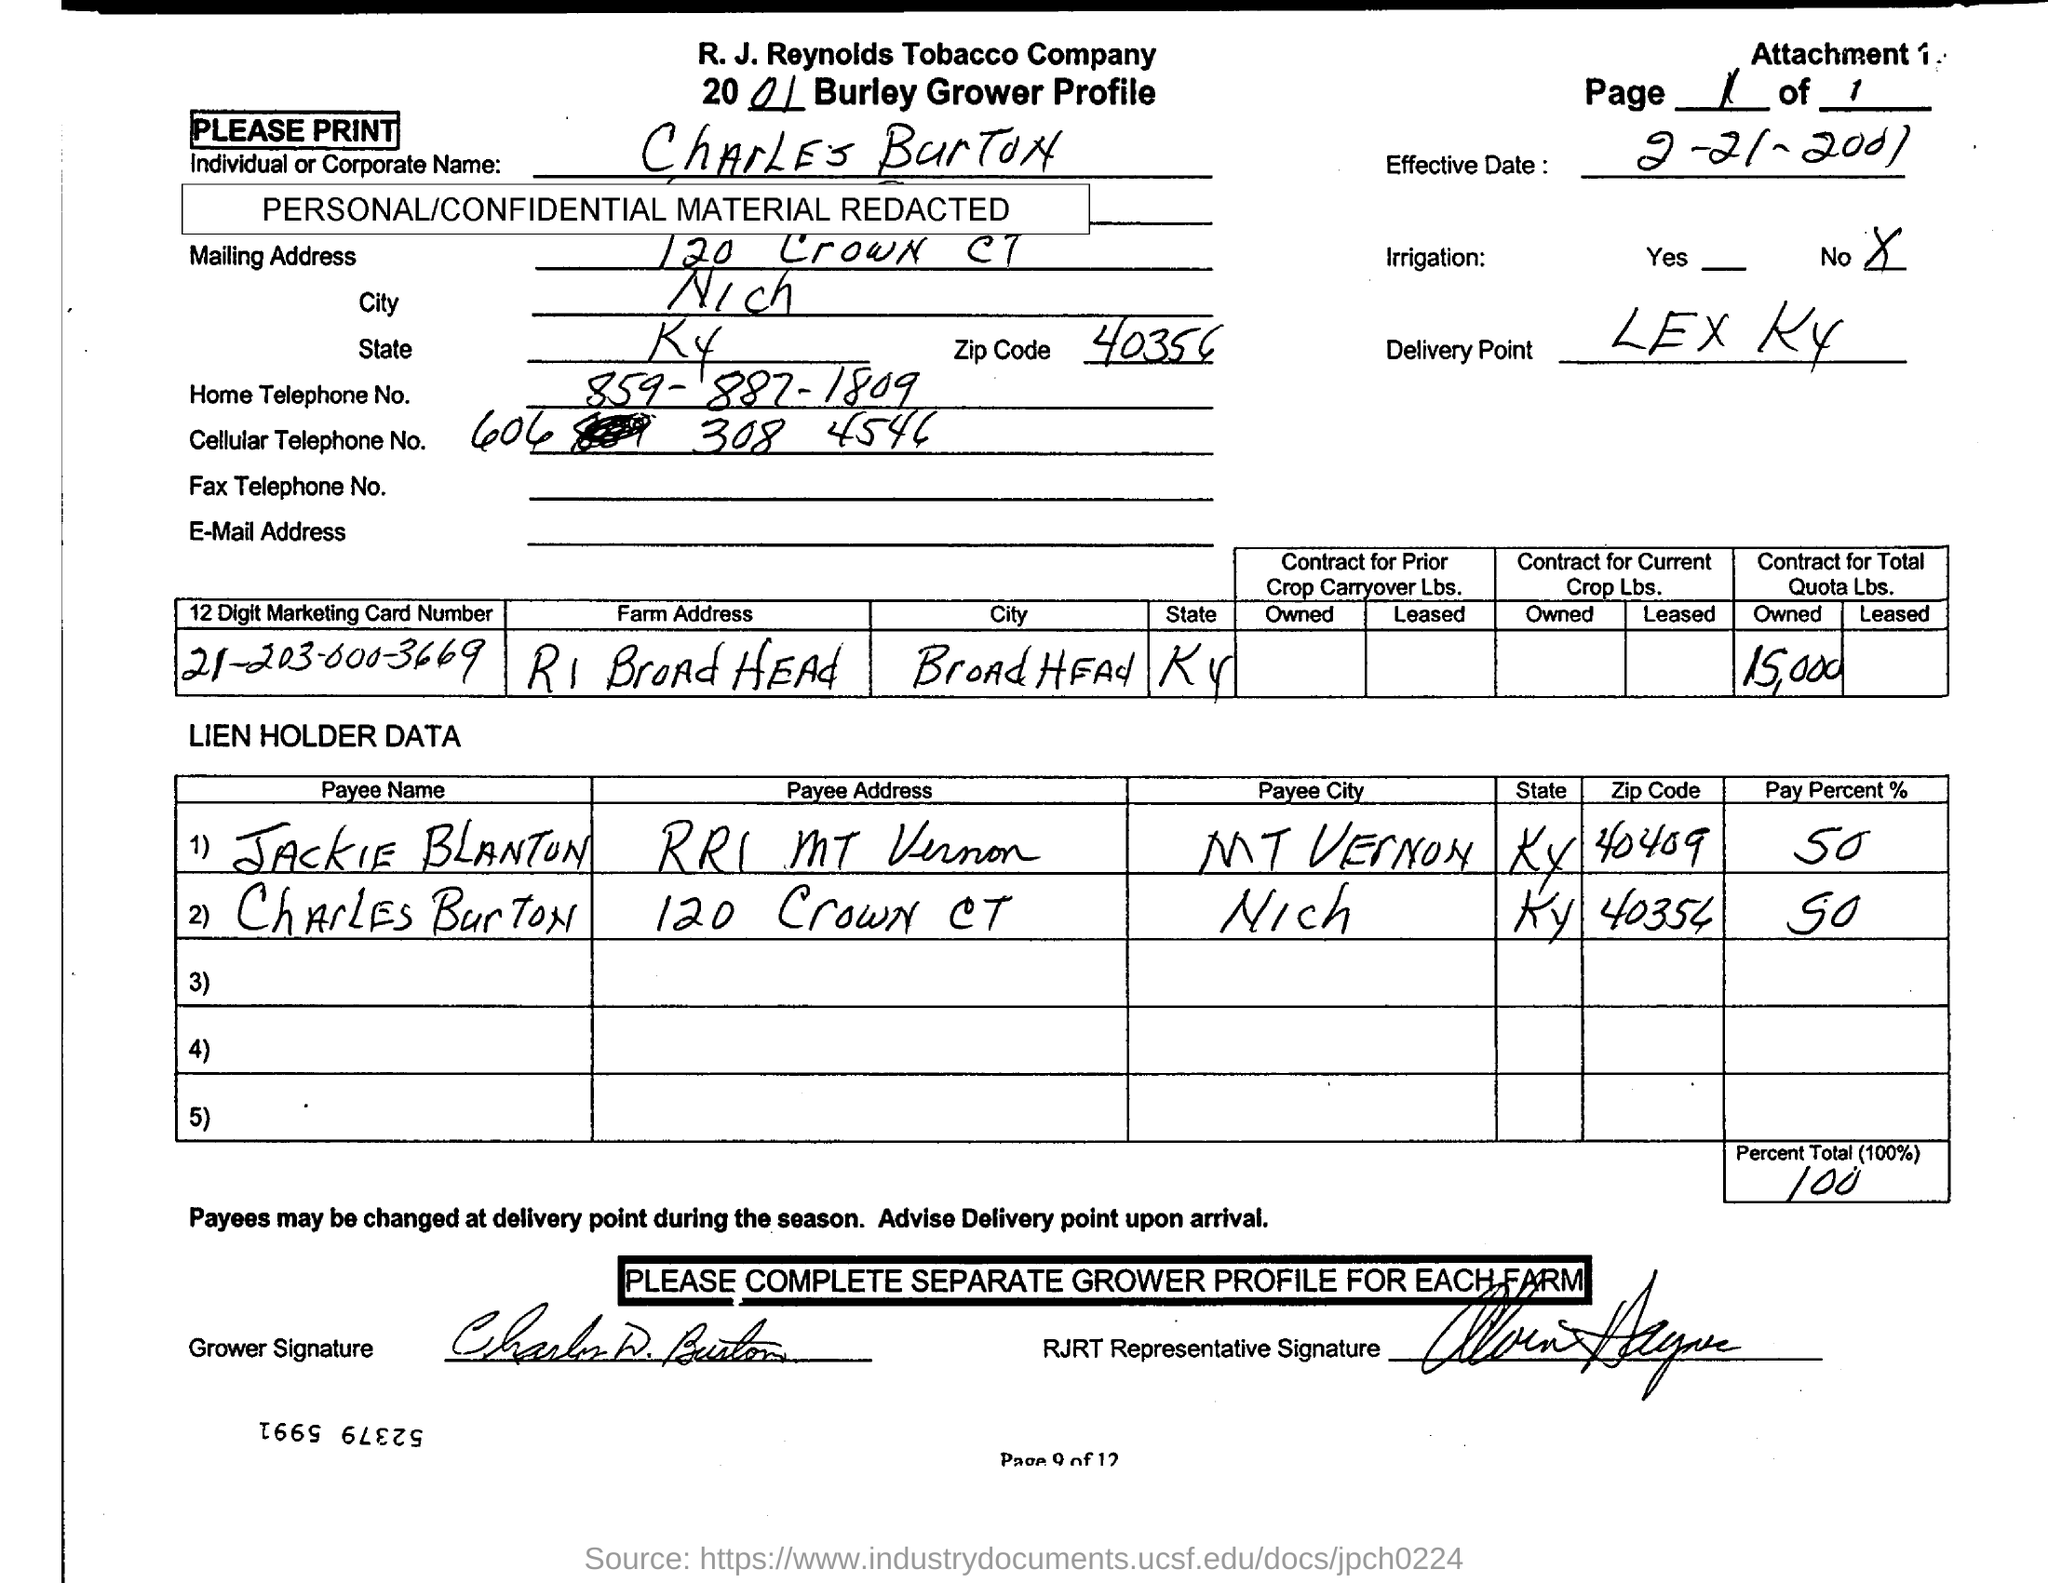Mention a couple of crucial points in this snapshot. It is Charles Burton. The 12-digit Marketing Card Number is 212030003669. I have recently been offered a new job with a pay rate of 50%. I am grateful for this opportunity, but I am concerned about the pay disparity between this position and my previous job. The delivery point is located at LEX KY. We own a Quota Lbs. contract worth 15,000. 